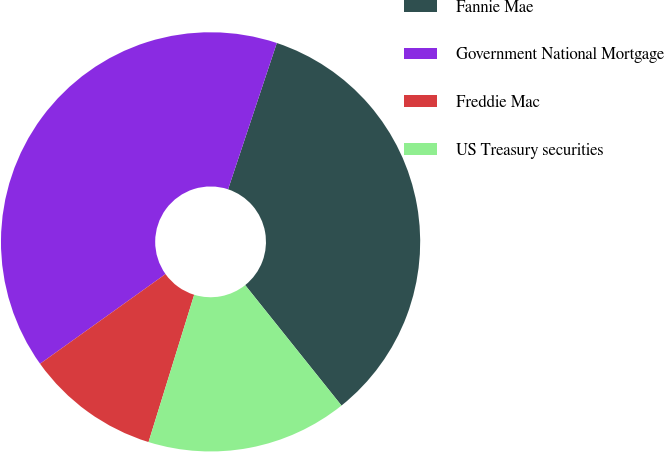Convert chart to OTSL. <chart><loc_0><loc_0><loc_500><loc_500><pie_chart><fcel>Fannie Mae<fcel>Government National Mortgage<fcel>Freddie Mac<fcel>US Treasury securities<nl><fcel>34.15%<fcel>40.0%<fcel>10.34%<fcel>15.52%<nl></chart> 